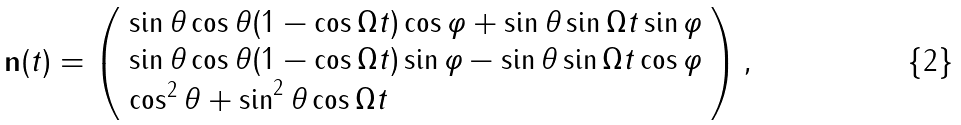<formula> <loc_0><loc_0><loc_500><loc_500>& \mathbf n ( t ) = \left ( \begin{array} { l } \sin \theta \cos \theta ( 1 - \cos \Omega t ) \cos \varphi + \sin \theta \sin \Omega t \sin \varphi \\ \sin \theta \cos \theta ( 1 - \cos \Omega t ) \sin \varphi - \sin \theta \sin \Omega t \cos \varphi \\ \cos ^ { 2 } \theta + \sin ^ { 2 } \theta \cos \Omega t \end{array} \right ) ,</formula> 